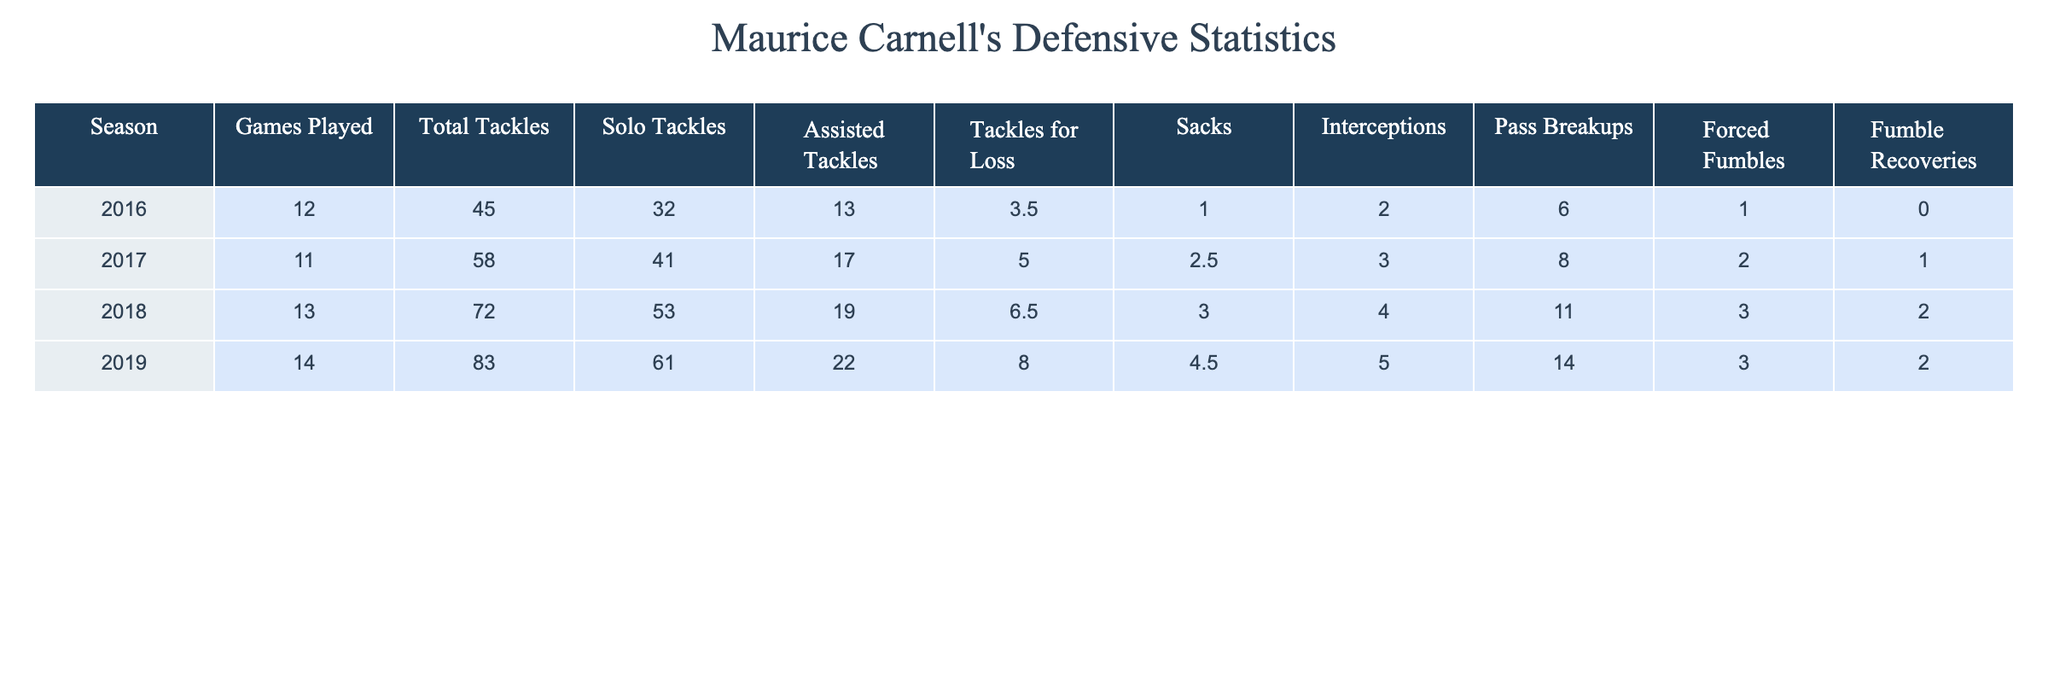What is the season with the highest total tackles? By looking at the "Total Tackles" column, we see that in 2019, there are 83 total tackles, which is the highest compared to other seasons.
Answer: 2019 How many interceptions did Maurice have in his best season? The "Interceptions" column reveals that in 2019, he had 4 interceptions, which is more than in any other season.
Answer: 4 What is the average number of sacks over his college career? Adding the sacks from each season: (1.0 + 2.5 + 3.0 + 4.5) = 11.0. There are 4 seasons, so the average is 11.0/4 = 2.75.
Answer: 2.75 Did Maurice have more assisted tackles or solo tackles in 2018? In 2018, he had 19 assisted tackles and 53 solo tackles, so he had more solo tackles than assisted tackles.
Answer: Yes What is the total number of forced fumbles over Maurice's college career? Adding the "Forced Fumbles" column: (1 + 2 + 3 + 14) = 20, which gives us the total number of forced fumbles across all seasons.
Answer: 20 Which season had the highest number of tackles for loss? The "Tackles for Loss" column indicates that 2019 had the highest with 8.0 tackles for loss.
Answer: 2019 What was his improvement in total tackles from 2016 to 2019? We calculate the difference by subtracting 2016's total tackles (45) from 2019's total tackles (83), resulting in 83 - 45 = 38.
Answer: 38 In which season did he have the most pass breakups? Reviewing the "Pass Breakups" column, we see that 2019 also had the highest count with 14 pass breakups.
Answer: 2019 How many fumble recoveries did he have in total? Summing the "Fumble Recoveries" column: (0 + 1 + 2 + 2) = 5, which reflects the total fumble recoveries over all seasons.
Answer: 5 Was there a season in which Maurice did not force a fumble? Based on the "Forced Fumbles" column, in 2016, he had 1 forced fumble, which shows that no season ended with 0 forced fumbles.
Answer: No 